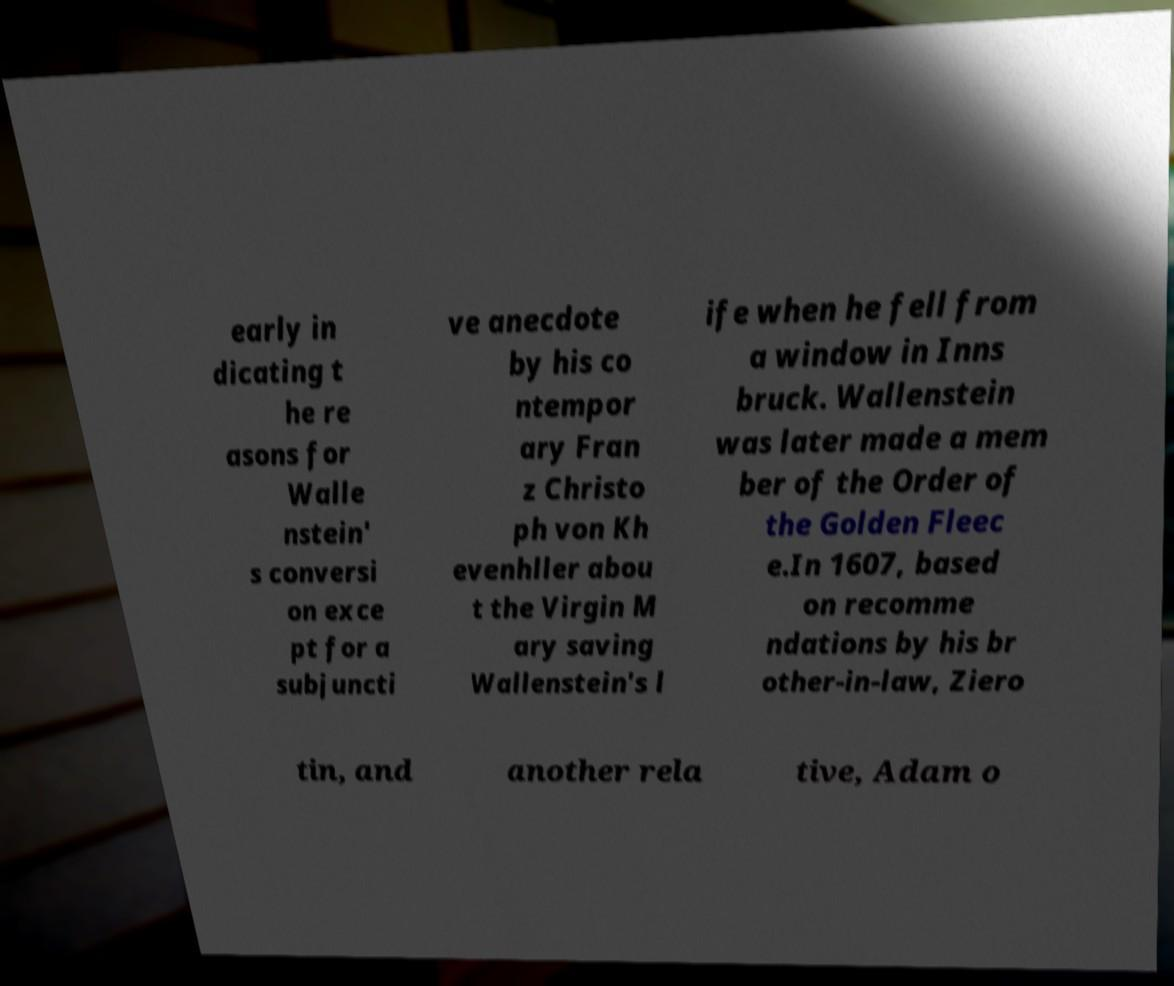Can you read and provide the text displayed in the image?This photo seems to have some interesting text. Can you extract and type it out for me? early in dicating t he re asons for Walle nstein' s conversi on exce pt for a subjuncti ve anecdote by his co ntempor ary Fran z Christo ph von Kh evenhller abou t the Virgin M ary saving Wallenstein's l ife when he fell from a window in Inns bruck. Wallenstein was later made a mem ber of the Order of the Golden Fleec e.In 1607, based on recomme ndations by his br other-in-law, Ziero tin, and another rela tive, Adam o 